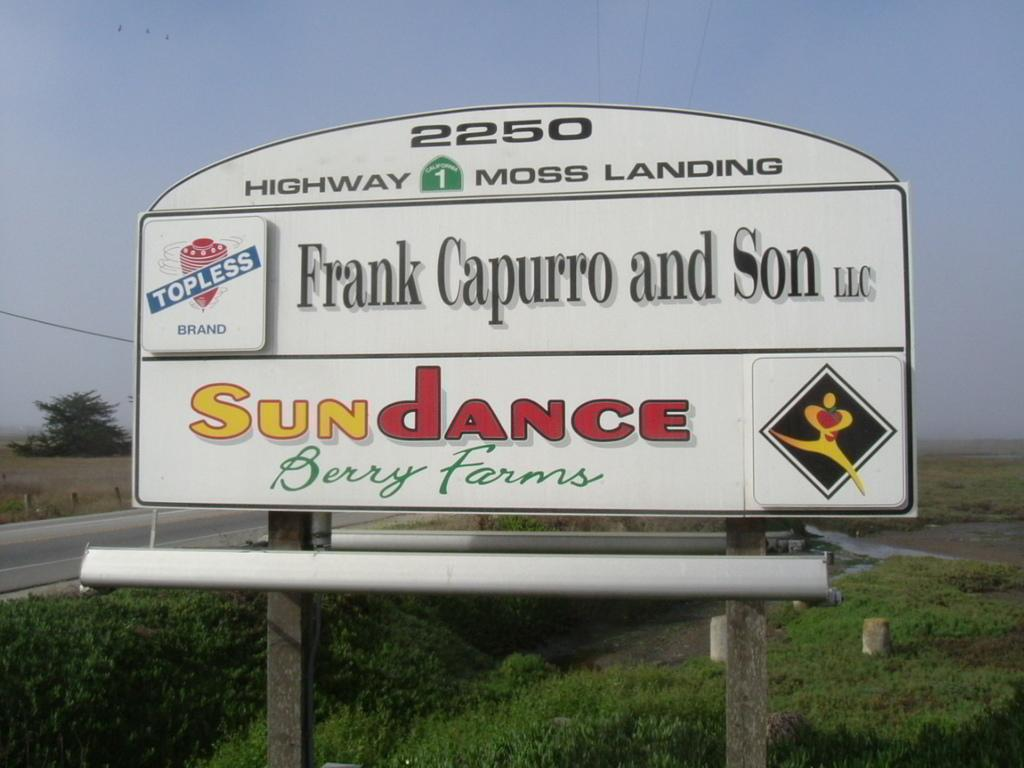<image>
Write a terse but informative summary of the picture. A billboard has 2250 highway moss landing and sundance in text. 